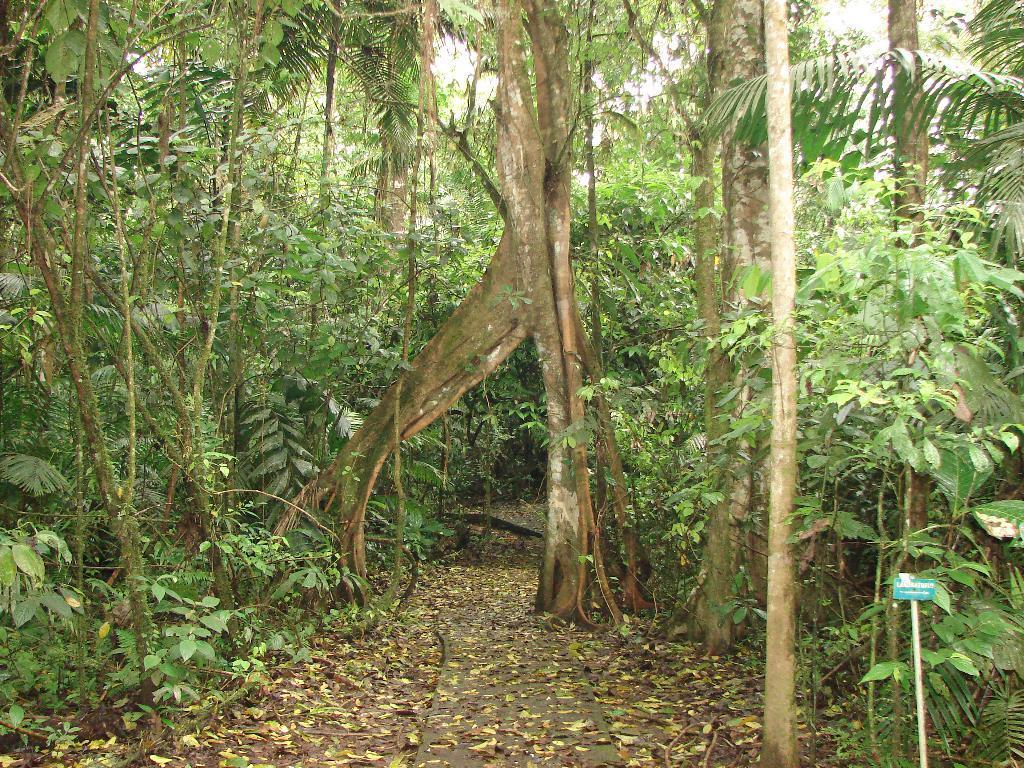Describe this image in one or two sentences. In this I can see there are green trees, at the bottom there are leaves. 